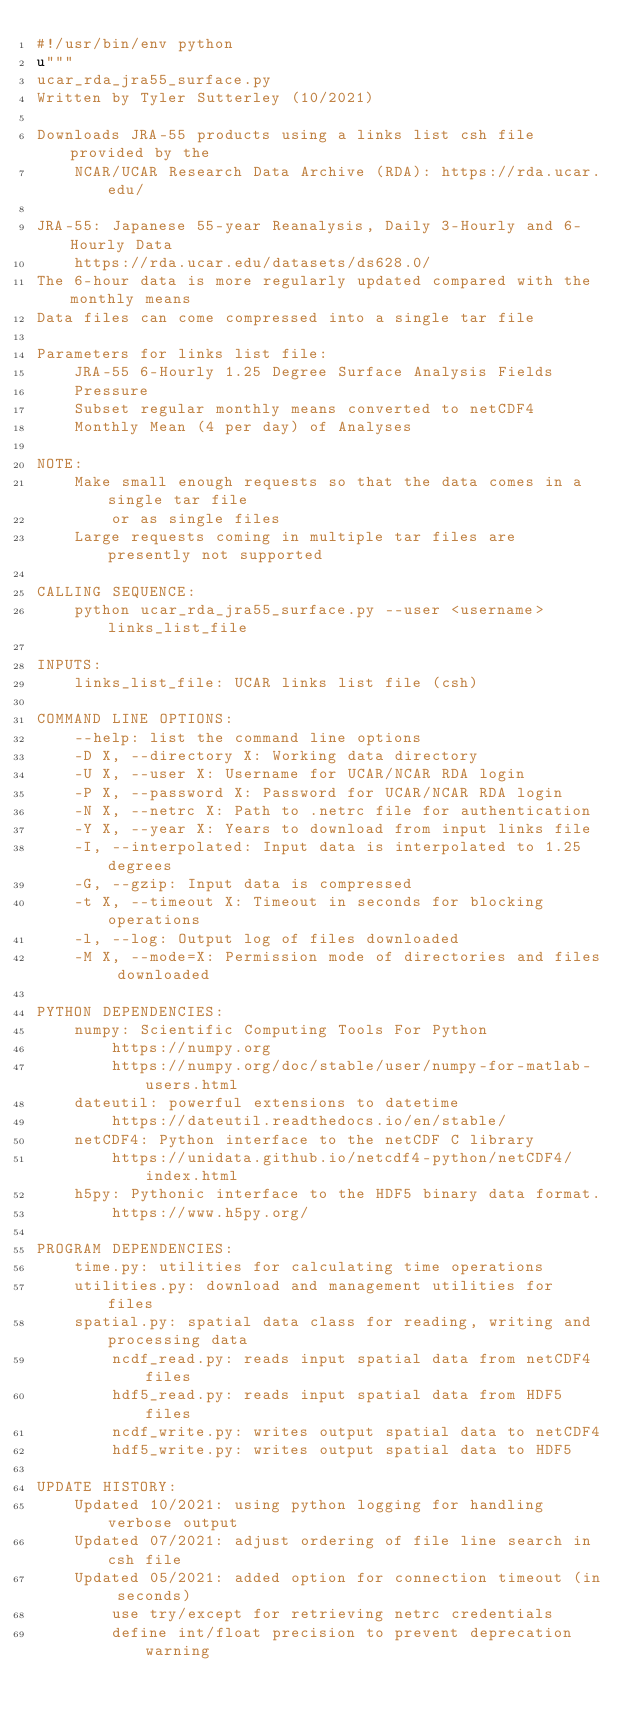Convert code to text. <code><loc_0><loc_0><loc_500><loc_500><_Python_>#!/usr/bin/env python
u"""
ucar_rda_jra55_surface.py
Written by Tyler Sutterley (10/2021)

Downloads JRA-55 products using a links list csh file provided by the
    NCAR/UCAR Research Data Archive (RDA): https://rda.ucar.edu/

JRA-55: Japanese 55-year Reanalysis, Daily 3-Hourly and 6-Hourly Data
    https://rda.ucar.edu/datasets/ds628.0/
The 6-hour data is more regularly updated compared with the monthly means
Data files can come compressed into a single tar file

Parameters for links list file:
    JRA-55 6-Hourly 1.25 Degree Surface Analysis Fields
    Pressure
    Subset regular monthly means converted to netCDF4
    Monthly Mean (4 per day) of Analyses

NOTE:
    Make small enough requests so that the data comes in a single tar file
        or as single files
    Large requests coming in multiple tar files are presently not supported

CALLING SEQUENCE:
    python ucar_rda_jra55_surface.py --user <username> links_list_file

INPUTS:
    links_list_file: UCAR links list file (csh)

COMMAND LINE OPTIONS:
    --help: list the command line options
    -D X, --directory X: Working data directory
    -U X, --user X: Username for UCAR/NCAR RDA login
    -P X, --password X: Password for UCAR/NCAR RDA login
    -N X, --netrc X: Path to .netrc file for authentication
    -Y X, --year X: Years to download from input links file
    -I, --interpolated: Input data is interpolated to 1.25 degrees
    -G, --gzip: Input data is compressed
    -t X, --timeout X: Timeout in seconds for blocking operations
    -l, --log: Output log of files downloaded
    -M X, --mode=X: Permission mode of directories and files downloaded

PYTHON DEPENDENCIES:
    numpy: Scientific Computing Tools For Python
        https://numpy.org
        https://numpy.org/doc/stable/user/numpy-for-matlab-users.html
    dateutil: powerful extensions to datetime
        https://dateutil.readthedocs.io/en/stable/
    netCDF4: Python interface to the netCDF C library
        https://unidata.github.io/netcdf4-python/netCDF4/index.html
    h5py: Pythonic interface to the HDF5 binary data format.
        https://www.h5py.org/

PROGRAM DEPENDENCIES:
    time.py: utilities for calculating time operations
    utilities.py: download and management utilities for files
    spatial.py: spatial data class for reading, writing and processing data
        ncdf_read.py: reads input spatial data from netCDF4 files
        hdf5_read.py: reads input spatial data from HDF5 files
        ncdf_write.py: writes output spatial data to netCDF4
        hdf5_write.py: writes output spatial data to HDF5

UPDATE HISTORY:
    Updated 10/2021: using python logging for handling verbose output
    Updated 07/2021: adjust ordering of file line search in csh file
    Updated 05/2021: added option for connection timeout (in seconds)
        use try/except for retrieving netrc credentials
        define int/float precision to prevent deprecation warning</code> 